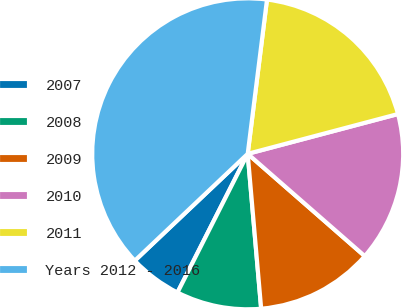Convert chart. <chart><loc_0><loc_0><loc_500><loc_500><pie_chart><fcel>2007<fcel>2008<fcel>2009<fcel>2010<fcel>2011<fcel>Years 2012 - 2016<nl><fcel>5.48%<fcel>8.84%<fcel>12.19%<fcel>15.55%<fcel>18.9%<fcel>39.04%<nl></chart> 